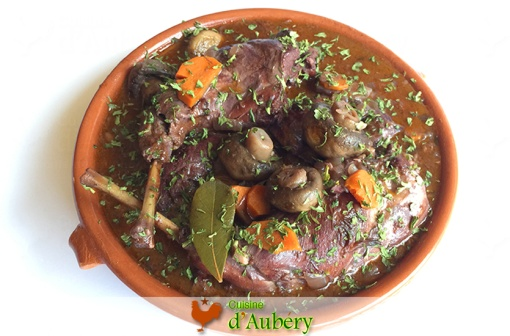Describe a short, realistic scenario for this dish. On a chilly evening in Paris, a small family gathers around their dinner table. The mother lifts the lid off a terracotta dish, revealing the steaming **Coq au Vin** inside. The aroma fills the room, eliciting smiles and eager anticipation. They serve the dish alongside a crusty baguette, enjoying each other’s company and the comforting meal. 